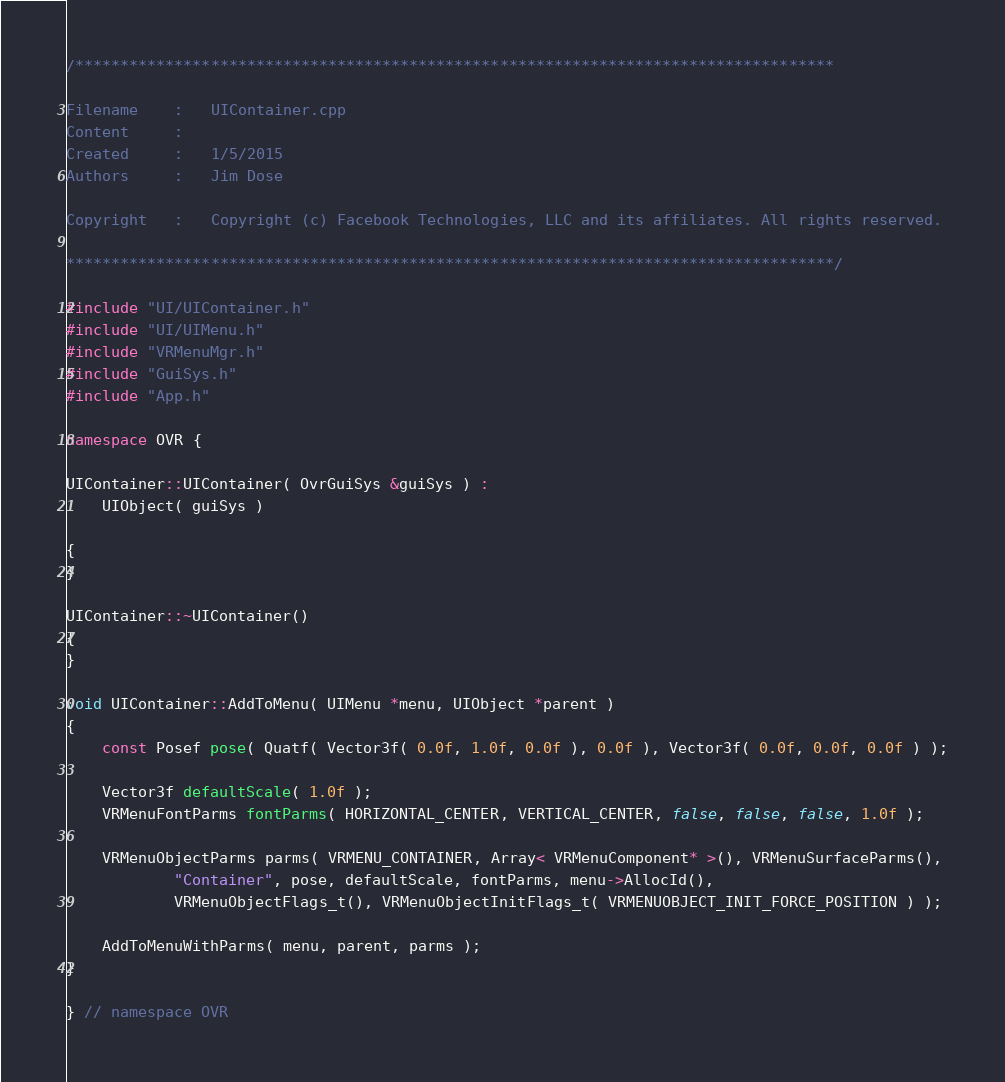<code> <loc_0><loc_0><loc_500><loc_500><_C++_>/************************************************************************************

Filename    :   UIContainer.cpp
Content     :
Created     :	1/5/2015
Authors     :   Jim Dose

Copyright   :   Copyright (c) Facebook Technologies, LLC and its affiliates. All rights reserved.

*************************************************************************************/

#include "UI/UIContainer.h"
#include "UI/UIMenu.h"
#include "VRMenuMgr.h"
#include "GuiSys.h"
#include "App.h"

namespace OVR {

UIContainer::UIContainer( OvrGuiSys &guiSys ) :
	UIObject( guiSys )

{
}

UIContainer::~UIContainer()
{
}

void UIContainer::AddToMenu( UIMenu *menu, UIObject *parent )
{
	const Posef pose( Quatf( Vector3f( 0.0f, 1.0f, 0.0f ), 0.0f ), Vector3f( 0.0f, 0.0f, 0.0f ) );

	Vector3f defaultScale( 1.0f );
	VRMenuFontParms fontParms( HORIZONTAL_CENTER, VERTICAL_CENTER, false, false, false, 1.0f );
	
	VRMenuObjectParms parms( VRMENU_CONTAINER, Array< VRMenuComponent* >(), VRMenuSurfaceParms(),
			"Container", pose, defaultScale, fontParms, menu->AllocId(),
			VRMenuObjectFlags_t(), VRMenuObjectInitFlags_t( VRMENUOBJECT_INIT_FORCE_POSITION ) );

	AddToMenuWithParms( menu, parent, parms );
}

} // namespace OVR
</code> 